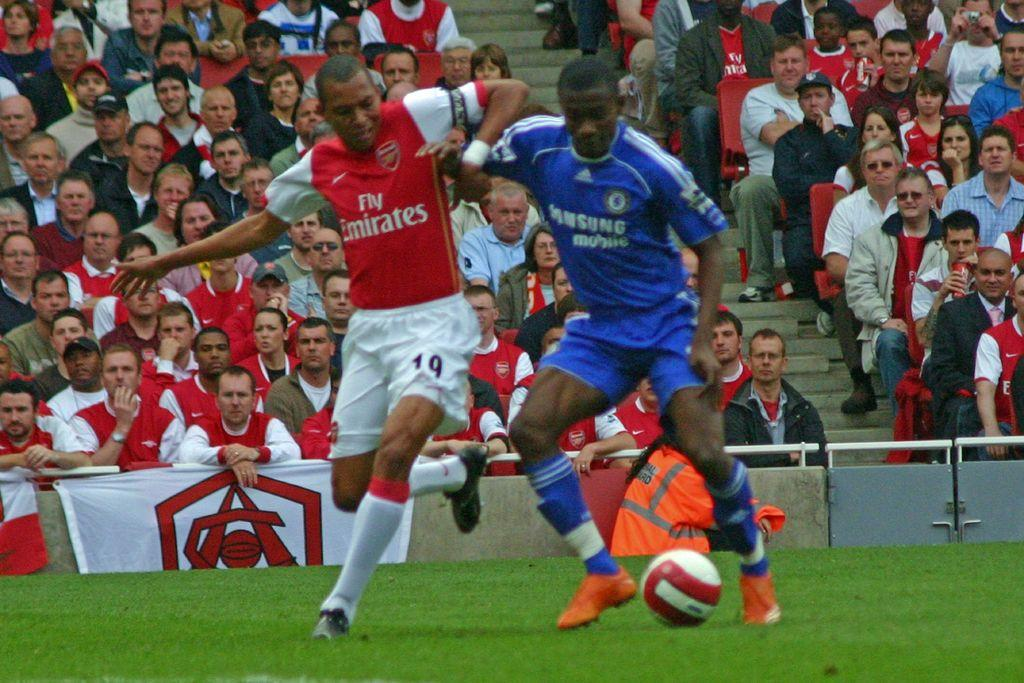<image>
Render a clear and concise summary of the photo. Two soccer players in a stadium with the one wearing the red jersey being number 19. 